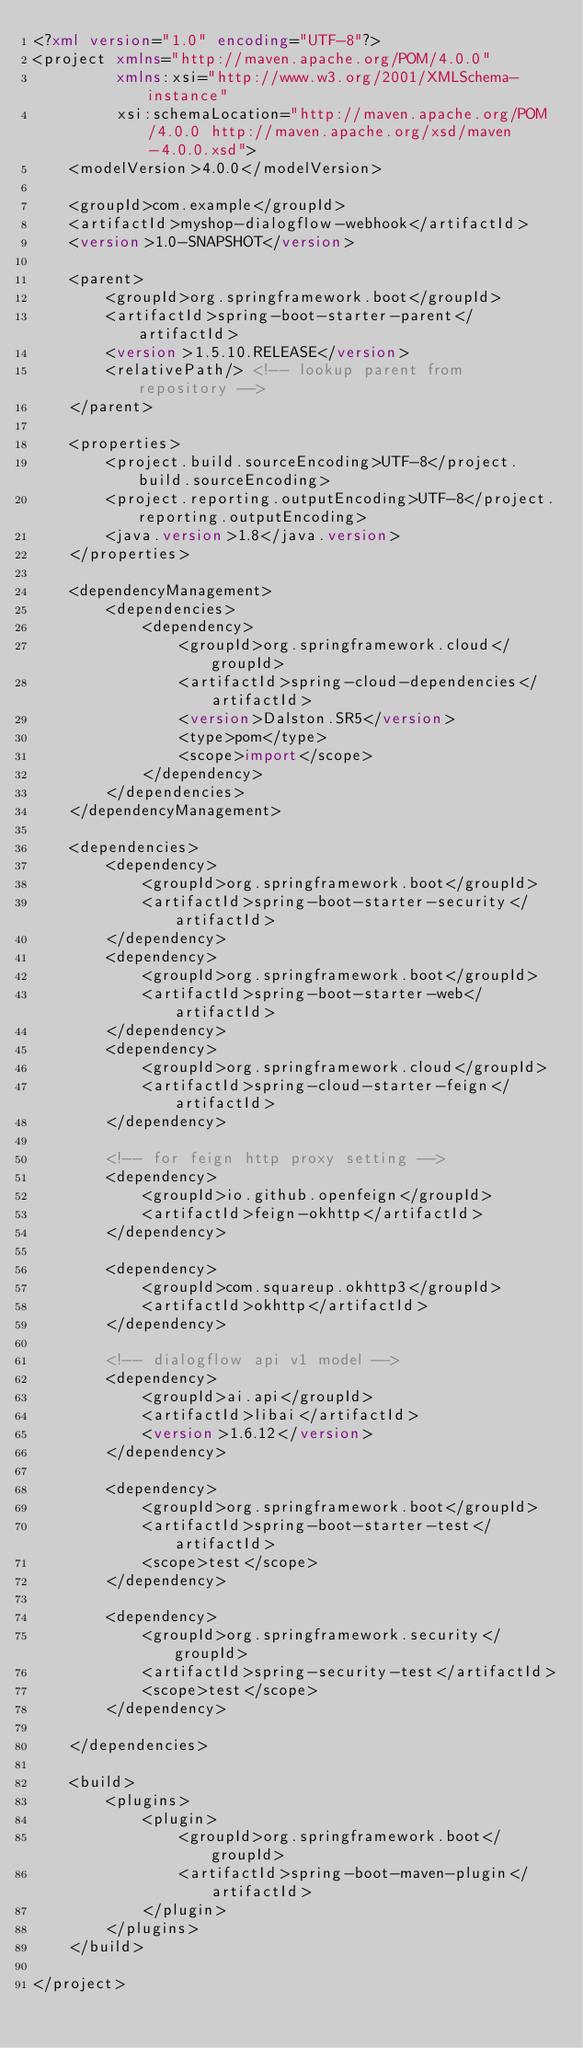<code> <loc_0><loc_0><loc_500><loc_500><_XML_><?xml version="1.0" encoding="UTF-8"?>
<project xmlns="http://maven.apache.org/POM/4.0.0"
         xmlns:xsi="http://www.w3.org/2001/XMLSchema-instance"
         xsi:schemaLocation="http://maven.apache.org/POM/4.0.0 http://maven.apache.org/xsd/maven-4.0.0.xsd">
    <modelVersion>4.0.0</modelVersion>

    <groupId>com.example</groupId>
    <artifactId>myshop-dialogflow-webhook</artifactId>
    <version>1.0-SNAPSHOT</version>

    <parent>
        <groupId>org.springframework.boot</groupId>
        <artifactId>spring-boot-starter-parent</artifactId>
        <version>1.5.10.RELEASE</version>
        <relativePath/> <!-- lookup parent from repository -->
    </parent>

    <properties>
        <project.build.sourceEncoding>UTF-8</project.build.sourceEncoding>
        <project.reporting.outputEncoding>UTF-8</project.reporting.outputEncoding>
        <java.version>1.8</java.version>
    </properties>

    <dependencyManagement>
        <dependencies>
            <dependency>
                <groupId>org.springframework.cloud</groupId>
                <artifactId>spring-cloud-dependencies</artifactId>
                <version>Dalston.SR5</version>
                <type>pom</type>
                <scope>import</scope>
            </dependency>
        </dependencies>
    </dependencyManagement>

    <dependencies>
        <dependency>
            <groupId>org.springframework.boot</groupId>
            <artifactId>spring-boot-starter-security</artifactId>
        </dependency>
        <dependency>
            <groupId>org.springframework.boot</groupId>
            <artifactId>spring-boot-starter-web</artifactId>
        </dependency>
        <dependency>
            <groupId>org.springframework.cloud</groupId>
            <artifactId>spring-cloud-starter-feign</artifactId>
        </dependency>

        <!-- for feign http proxy setting -->
        <dependency>
            <groupId>io.github.openfeign</groupId>
            <artifactId>feign-okhttp</artifactId>
        </dependency>

        <dependency>
            <groupId>com.squareup.okhttp3</groupId>
            <artifactId>okhttp</artifactId>
        </dependency>

        <!-- dialogflow api v1 model -->
        <dependency>
            <groupId>ai.api</groupId>
            <artifactId>libai</artifactId>
            <version>1.6.12</version>
        </dependency>

        <dependency>
            <groupId>org.springframework.boot</groupId>
            <artifactId>spring-boot-starter-test</artifactId>
            <scope>test</scope>
        </dependency>

        <dependency>
            <groupId>org.springframework.security</groupId>
            <artifactId>spring-security-test</artifactId>
            <scope>test</scope>
        </dependency>

    </dependencies>

    <build>
        <plugins>
            <plugin>
                <groupId>org.springframework.boot</groupId>
                <artifactId>spring-boot-maven-plugin</artifactId>
            </plugin>
        </plugins>
    </build>

</project></code> 